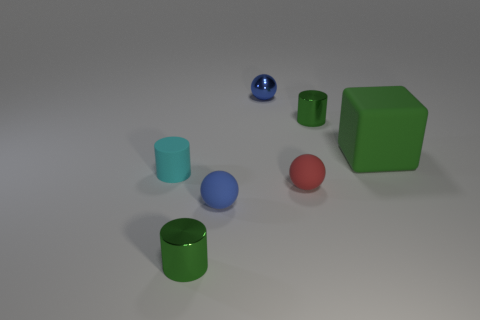How many objects are either tiny red things or green cylinders that are in front of the cyan thing? Upon observing the image, it appears that there are two objects that meet the specified criteria: one tiny red ball and one green cylinder positioned in front of the large cyan cylinder. Therefore, a total of two objects correspond to your query. 